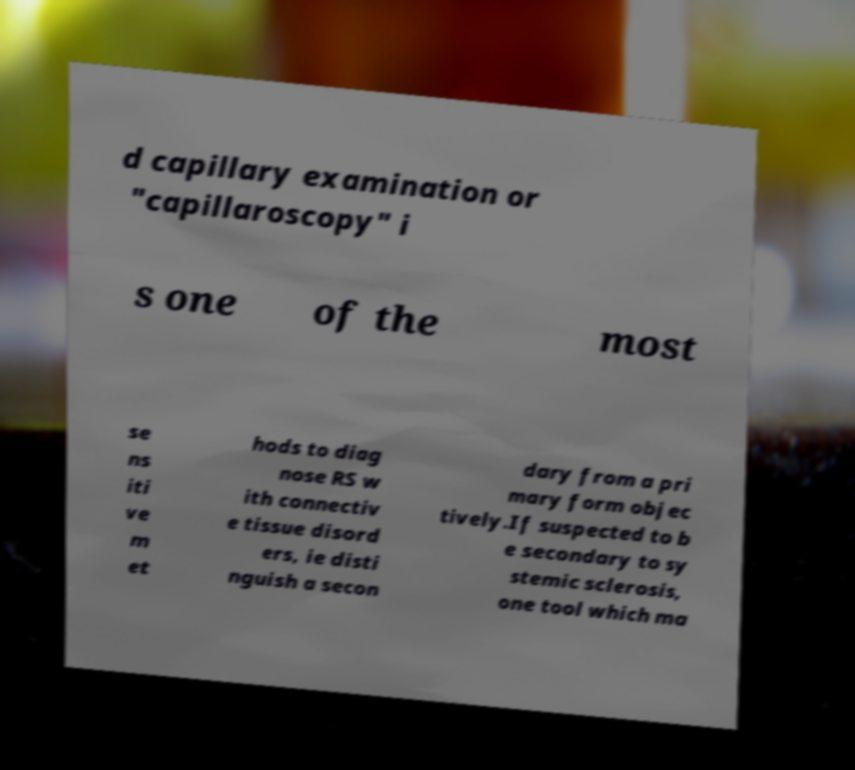Please read and relay the text visible in this image. What does it say? d capillary examination or "capillaroscopy" i s one of the most se ns iti ve m et hods to diag nose RS w ith connectiv e tissue disord ers, ie disti nguish a secon dary from a pri mary form objec tively.If suspected to b e secondary to sy stemic sclerosis, one tool which ma 